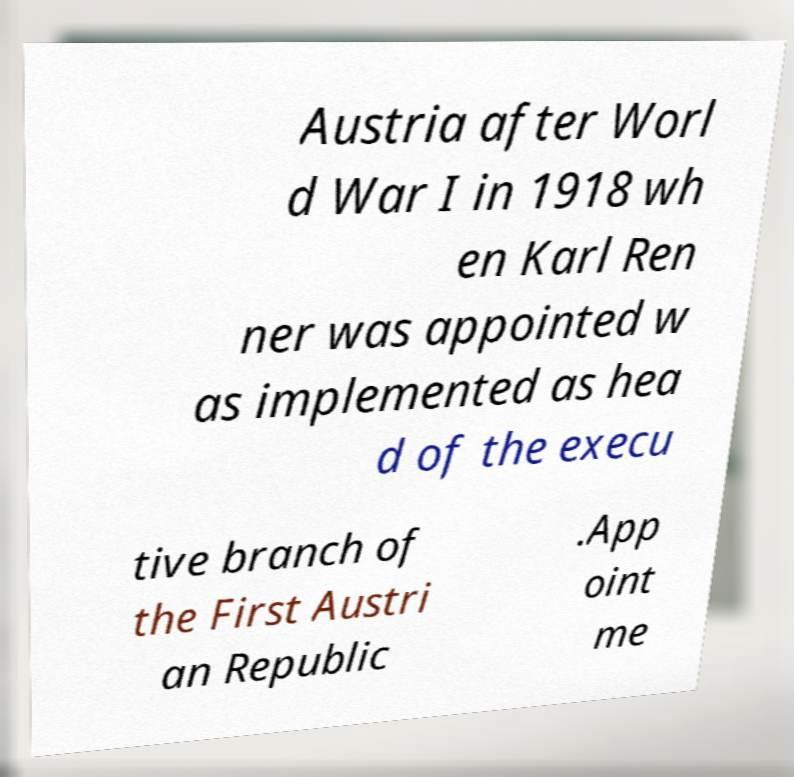There's text embedded in this image that I need extracted. Can you transcribe it verbatim? Austria after Worl d War I in 1918 wh en Karl Ren ner was appointed w as implemented as hea d of the execu tive branch of the First Austri an Republic .App oint me 